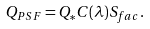<formula> <loc_0><loc_0><loc_500><loc_500>Q _ { P S F } = Q _ { * } C ( \lambda ) S _ { f a c } .</formula> 